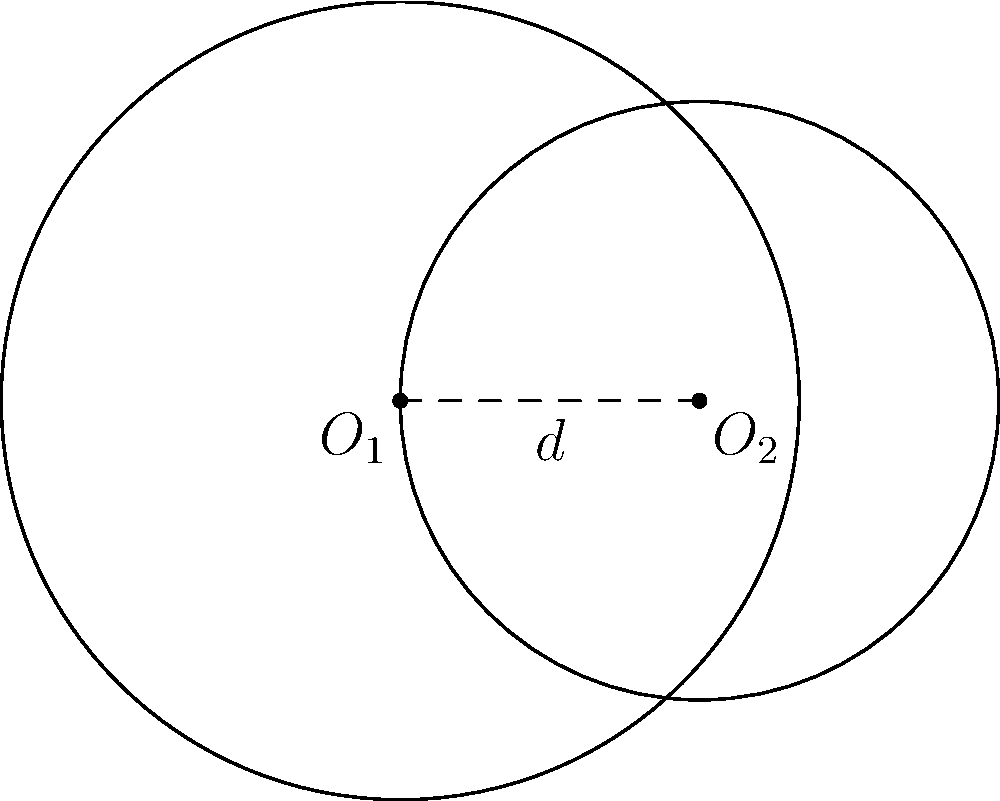Given two circles with centers $O_1$ and $O_2$, radii $r_1 = 4$ and $r_2 = 3$, and a distance $d = 3$ between their centers, calculate the area of their intersection. Express your answer in terms of $\pi$ and round to two decimal places. To solve this problem, we'll use the formula for the area of intersection of two circles:

1) Area = $r_1^2 \arccos(\frac{d^2 + r_1^2 - r_2^2}{2dr_1}) + r_2^2 \arccos(\frac{d^2 + r_2^2 - r_1^2}{2dr_2}) - \frac{1}{2}\sqrt{(-d+r_1+r_2)(d+r_1-r_2)(d-r_1+r_2)(d+r_1+r_2)}$

2) Substitute the given values: $r_1 = 4$, $r_2 = 3$, $d = 3$

3) Calculate the first term:
   $4^2 \arccos(\frac{3^2 + 4^2 - 3^2}{2 \cdot 3 \cdot 4}) = 16 \arccos(\frac{25}{24}) \approx 16 \cdot 0.2526 = 4.0416$

4) Calculate the second term:
   $3^2 \arccos(\frac{3^2 + 3^2 - 4^2}{2 \cdot 3 \cdot 3}) = 9 \arccos(\frac{2}{9}) \approx 9 \cdot 1.3694 = 12.3246$

5) Calculate the third term:
   $\frac{1}{2}\sqrt{(-3+4+3)(3+4-3)(3-4+3)(3+4+3)} = \frac{1}{2}\sqrt{4 \cdot 4 \cdot 2 \cdot 10} = \sqrt{160} = 4\sqrt{10}$

6) Sum up the terms:
   Area $\approx 4.0416 + 12.3246 - 4\sqrt{10} \approx 16.3662 - 12.6491 = 3.7171$

7) Round to two decimal places: 3.72

Therefore, the area of intersection is approximately $3.72\pi$ square units.
Answer: $3.72\pi$ square units 